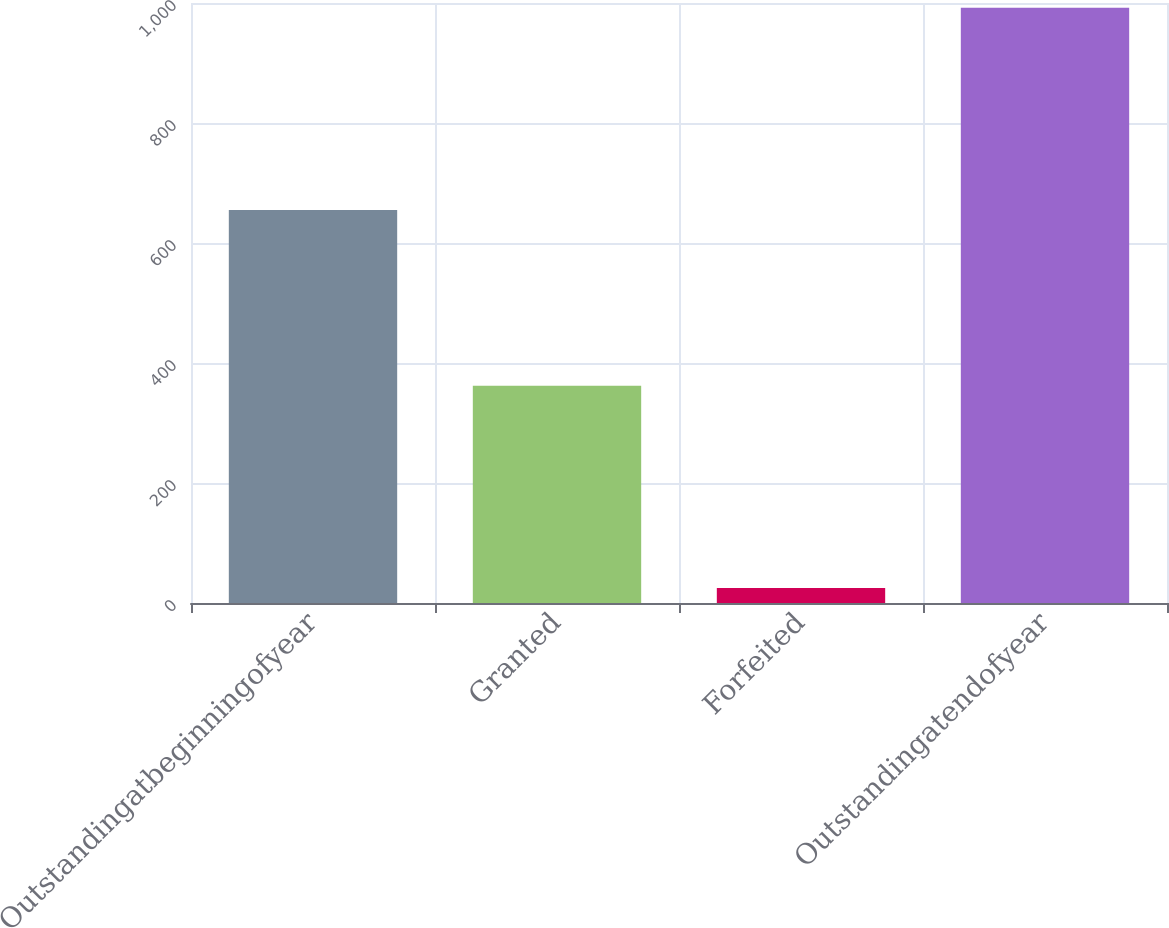Convert chart. <chart><loc_0><loc_0><loc_500><loc_500><bar_chart><fcel>Outstandingatbeginningofyear<fcel>Granted<fcel>Forfeited<fcel>Outstandingatendofyear<nl><fcel>655<fcel>362<fcel>25<fcel>992<nl></chart> 